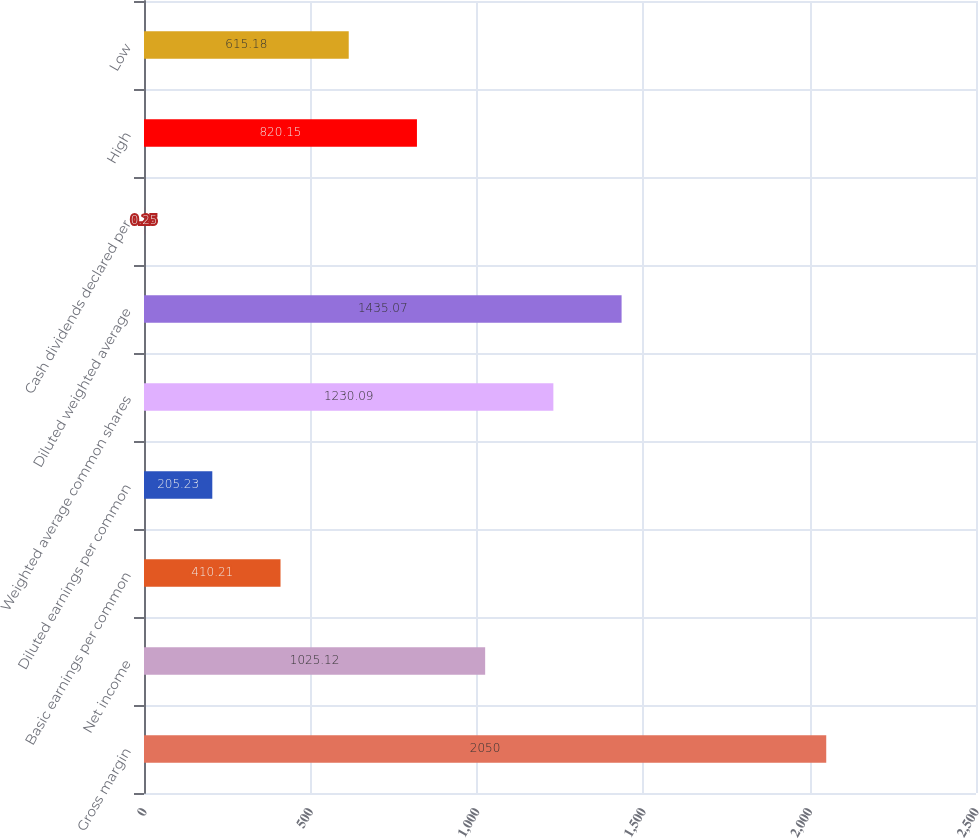Convert chart to OTSL. <chart><loc_0><loc_0><loc_500><loc_500><bar_chart><fcel>Gross margin<fcel>Net income<fcel>Basic earnings per common<fcel>Diluted earnings per common<fcel>Weighted average common shares<fcel>Diluted weighted average<fcel>Cash dividends declared per<fcel>High<fcel>Low<nl><fcel>2050<fcel>1025.12<fcel>410.21<fcel>205.23<fcel>1230.09<fcel>1435.07<fcel>0.25<fcel>820.15<fcel>615.18<nl></chart> 